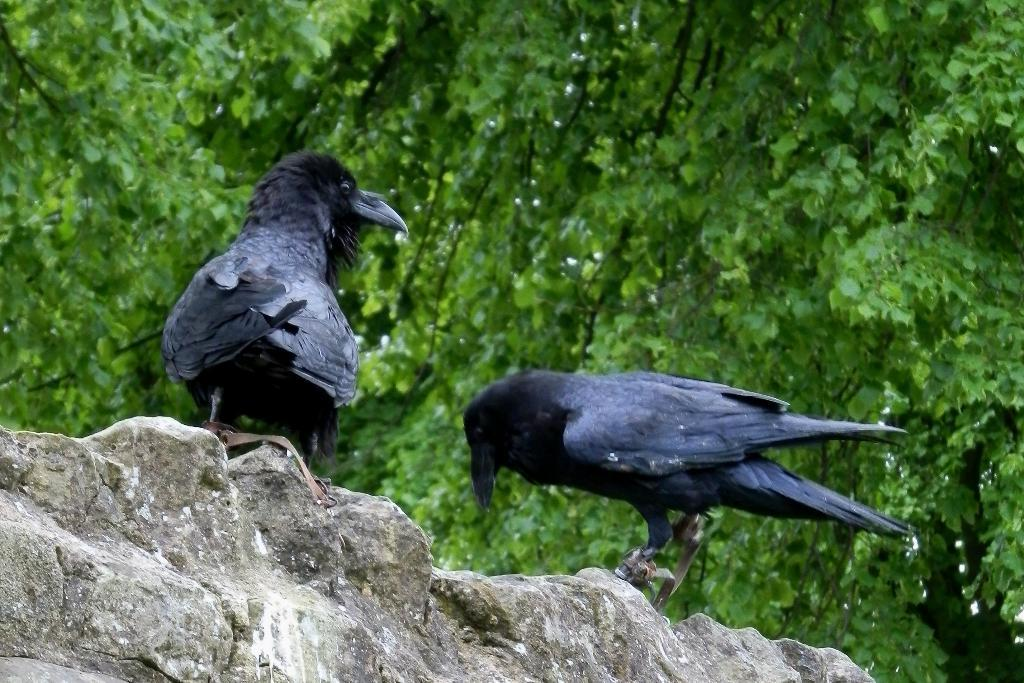How many birds can be seen in the image? There are two birds in the image. Where are the birds located? The birds are on a stone wall. What can be seen in the background of the image? There are trees visible in the background of the image. What type of jewel is the bird wearing on its back in the image? There are no jewels present on the birds in the image; they are simply birds sitting on a stone wall. 